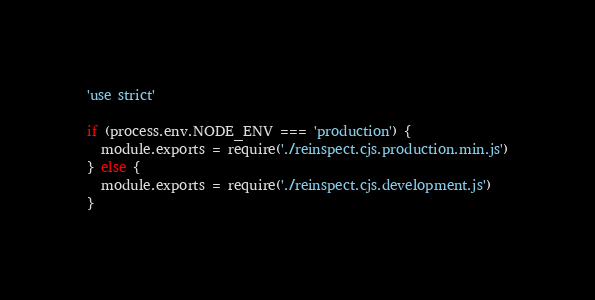<code> <loc_0><loc_0><loc_500><loc_500><_JavaScript_>
'use strict'

if (process.env.NODE_ENV === 'production') {
  module.exports = require('./reinspect.cjs.production.min.js')
} else {
  module.exports = require('./reinspect.cjs.development.js')
}
</code> 